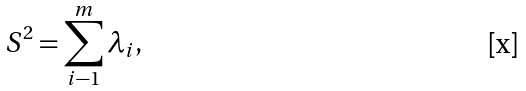<formula> <loc_0><loc_0><loc_500><loc_500>S ^ { 2 } = \sum _ { i - 1 } ^ { m } \lambda _ { i } ,</formula> 